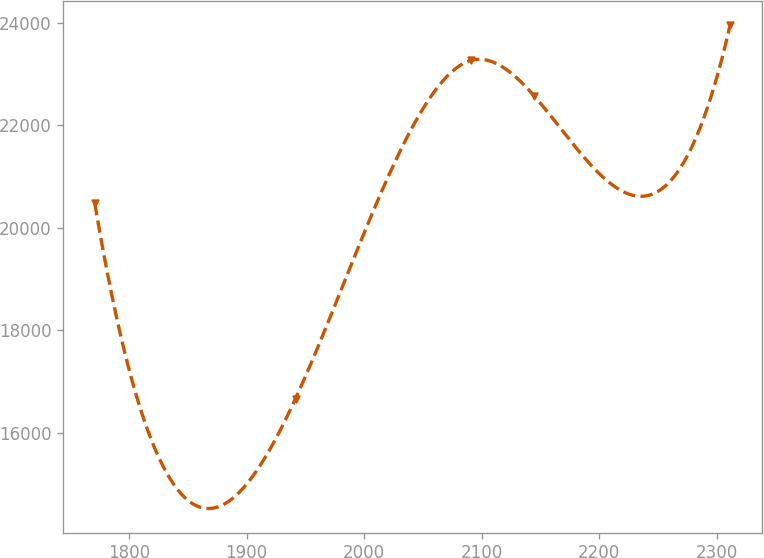<chart> <loc_0><loc_0><loc_500><loc_500><line_chart><ecel><fcel>Unnamed: 1<nl><fcel>1770.71<fcel>20483.7<nl><fcel>1941.6<fcel>16666.1<nl><fcel>2090.81<fcel>23268.5<nl><fcel>2144.9<fcel>22572.1<nl><fcel>2311.62<fcel>23964.9<nl></chart> 